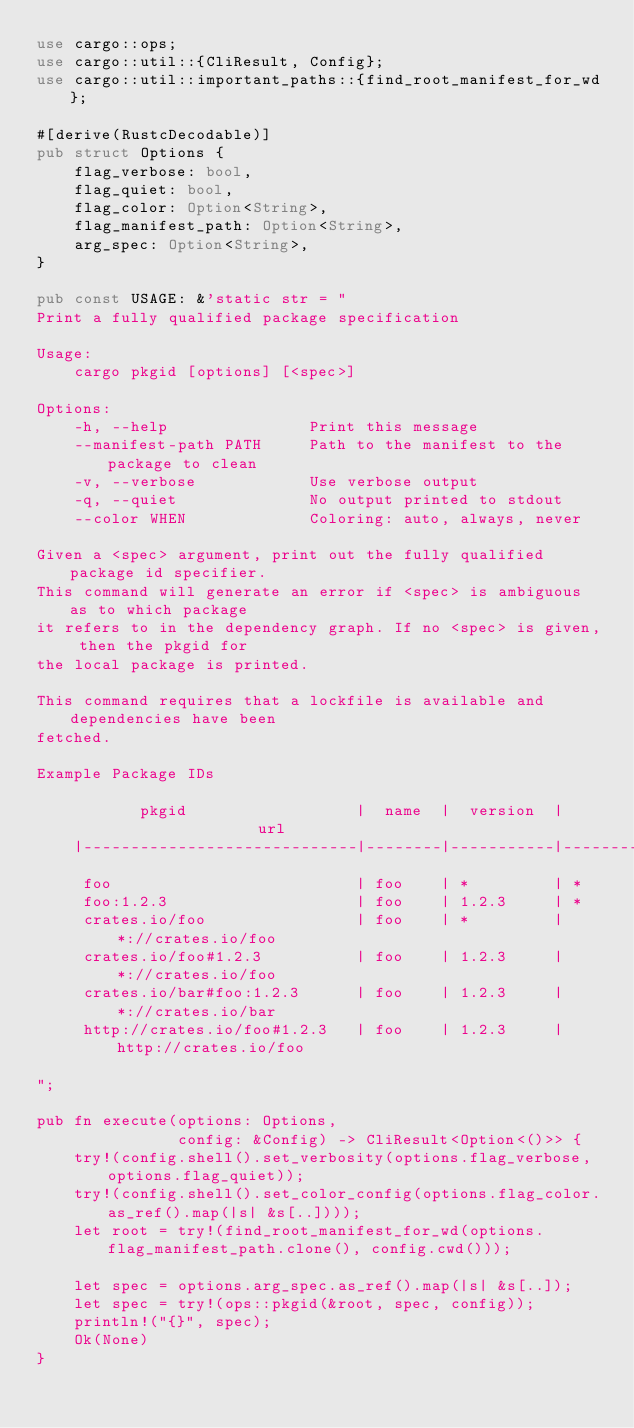Convert code to text. <code><loc_0><loc_0><loc_500><loc_500><_Rust_>use cargo::ops;
use cargo::util::{CliResult, Config};
use cargo::util::important_paths::{find_root_manifest_for_wd};

#[derive(RustcDecodable)]
pub struct Options {
    flag_verbose: bool,
    flag_quiet: bool,
    flag_color: Option<String>,
    flag_manifest_path: Option<String>,
    arg_spec: Option<String>,
}

pub const USAGE: &'static str = "
Print a fully qualified package specification

Usage:
    cargo pkgid [options] [<spec>]

Options:
    -h, --help               Print this message
    --manifest-path PATH     Path to the manifest to the package to clean
    -v, --verbose            Use verbose output
    -q, --quiet              No output printed to stdout
    --color WHEN             Coloring: auto, always, never

Given a <spec> argument, print out the fully qualified package id specifier.
This command will generate an error if <spec> is ambiguous as to which package
it refers to in the dependency graph. If no <spec> is given, then the pkgid for
the local package is printed.

This command requires that a lockfile is available and dependencies have been
fetched.

Example Package IDs

           pkgid                  |  name  |  version  |          url
    |-----------------------------|--------|-----------|---------------------|
     foo                          | foo    | *         | *
     foo:1.2.3                    | foo    | 1.2.3     | *
     crates.io/foo                | foo    | *         | *://crates.io/foo
     crates.io/foo#1.2.3          | foo    | 1.2.3     | *://crates.io/foo
     crates.io/bar#foo:1.2.3      | foo    | 1.2.3     | *://crates.io/bar
     http://crates.io/foo#1.2.3   | foo    | 1.2.3     | http://crates.io/foo

";

pub fn execute(options: Options,
               config: &Config) -> CliResult<Option<()>> {
    try!(config.shell().set_verbosity(options.flag_verbose, options.flag_quiet));
    try!(config.shell().set_color_config(options.flag_color.as_ref().map(|s| &s[..])));
    let root = try!(find_root_manifest_for_wd(options.flag_manifest_path.clone(), config.cwd()));

    let spec = options.arg_spec.as_ref().map(|s| &s[..]);
    let spec = try!(ops::pkgid(&root, spec, config));
    println!("{}", spec);
    Ok(None)
}

</code> 